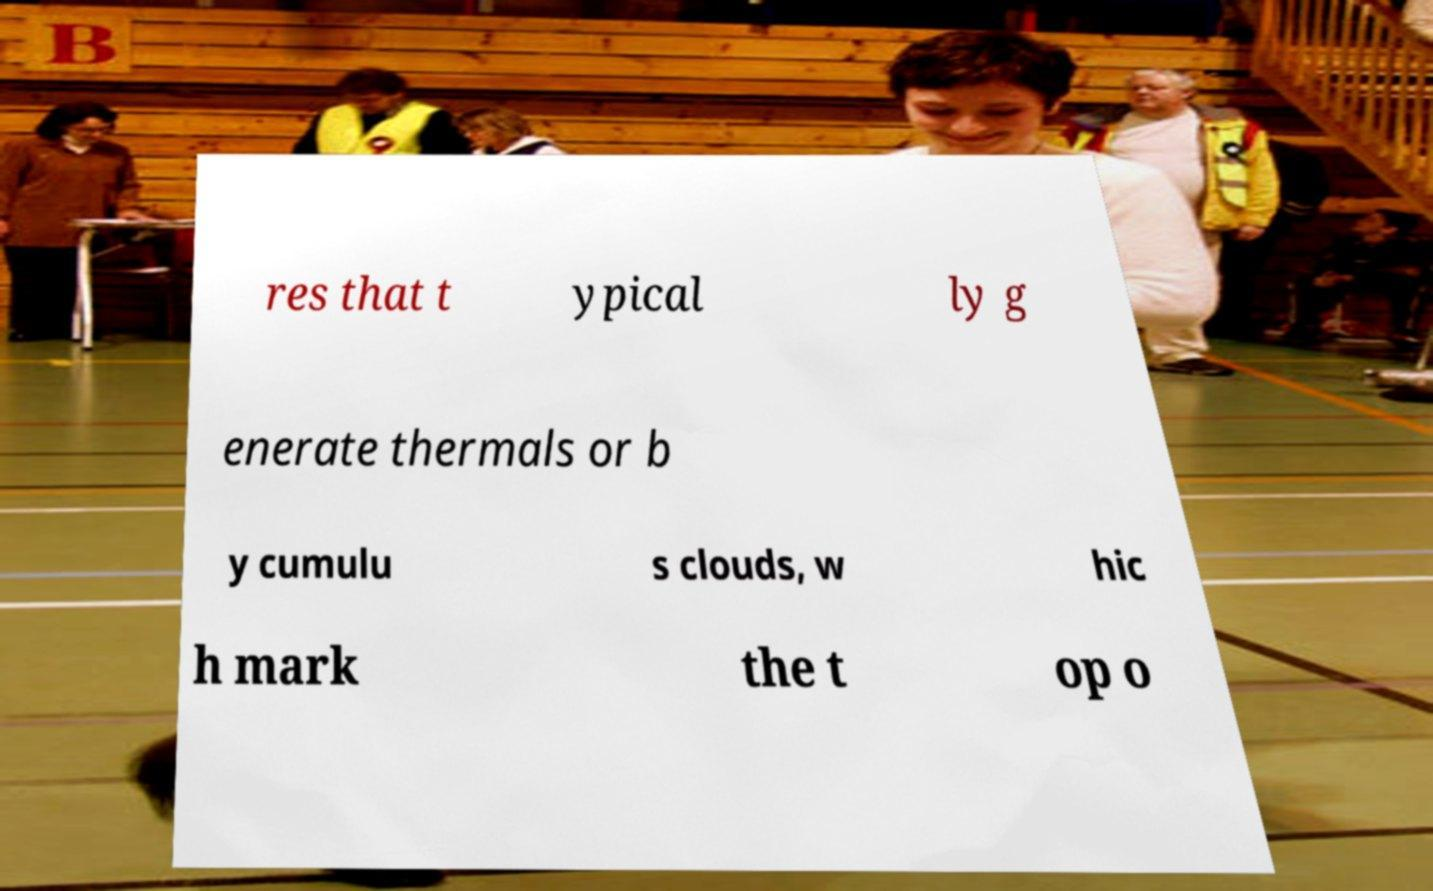Can you accurately transcribe the text from the provided image for me? res that t ypical ly g enerate thermals or b y cumulu s clouds, w hic h mark the t op o 